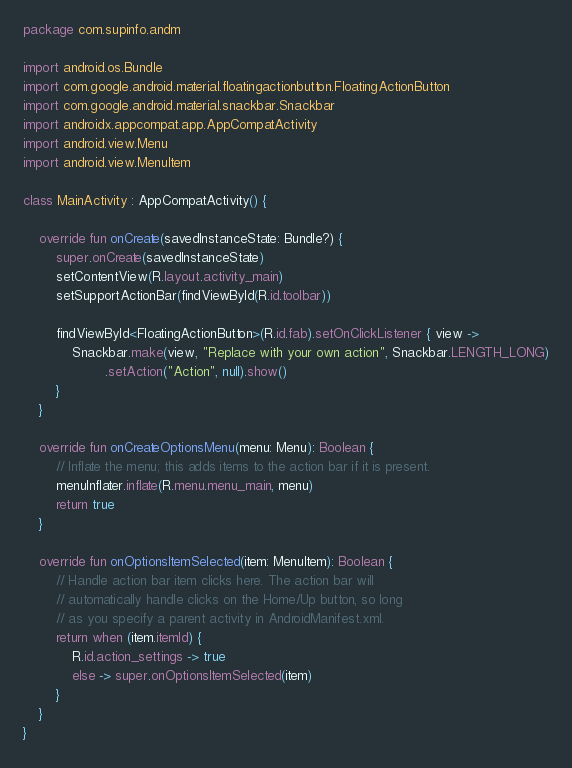<code> <loc_0><loc_0><loc_500><loc_500><_Kotlin_>package com.supinfo.andm

import android.os.Bundle
import com.google.android.material.floatingactionbutton.FloatingActionButton
import com.google.android.material.snackbar.Snackbar
import androidx.appcompat.app.AppCompatActivity
import android.view.Menu
import android.view.MenuItem

class MainActivity : AppCompatActivity() {

    override fun onCreate(savedInstanceState: Bundle?) {
        super.onCreate(savedInstanceState)
        setContentView(R.layout.activity_main)
        setSupportActionBar(findViewById(R.id.toolbar))

        findViewById<FloatingActionButton>(R.id.fab).setOnClickListener { view ->
            Snackbar.make(view, "Replace with your own action", Snackbar.LENGTH_LONG)
                    .setAction("Action", null).show()
        }
    }

    override fun onCreateOptionsMenu(menu: Menu): Boolean {
        // Inflate the menu; this adds items to the action bar if it is present.
        menuInflater.inflate(R.menu.menu_main, menu)
        return true
    }

    override fun onOptionsItemSelected(item: MenuItem): Boolean {
        // Handle action bar item clicks here. The action bar will
        // automatically handle clicks on the Home/Up button, so long
        // as you specify a parent activity in AndroidManifest.xml.
        return when (item.itemId) {
            R.id.action_settings -> true
            else -> super.onOptionsItemSelected(item)
        }
    }
}</code> 